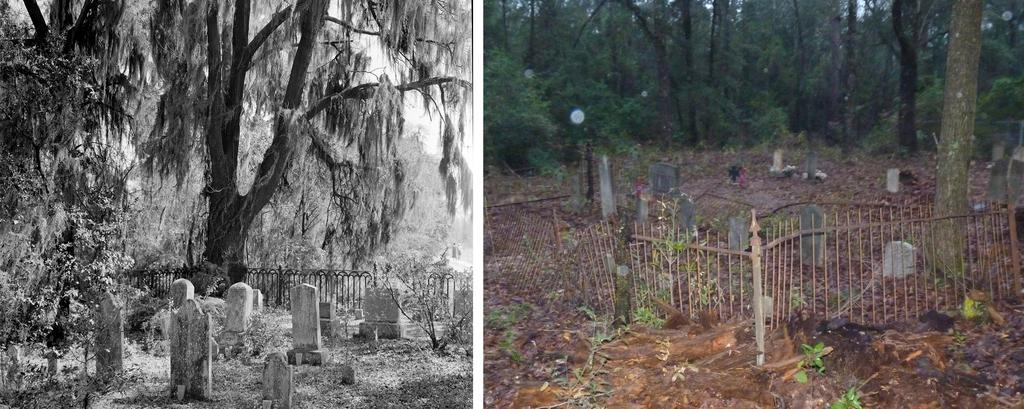What type of artwork is depicted in the image? The image is a collage. What can be seen on the headstones in the image? The details on the headstones are not visible in the image. What type of vegetation is present in the image? There are trees in the image. What type of fence is visible in the image? There is a metal rod fence in the image. How many eggs are visible in the image? There are no eggs present in the image. What type of bag is hanging on the tree in the image? There is no bag hanging on the tree in the image. 